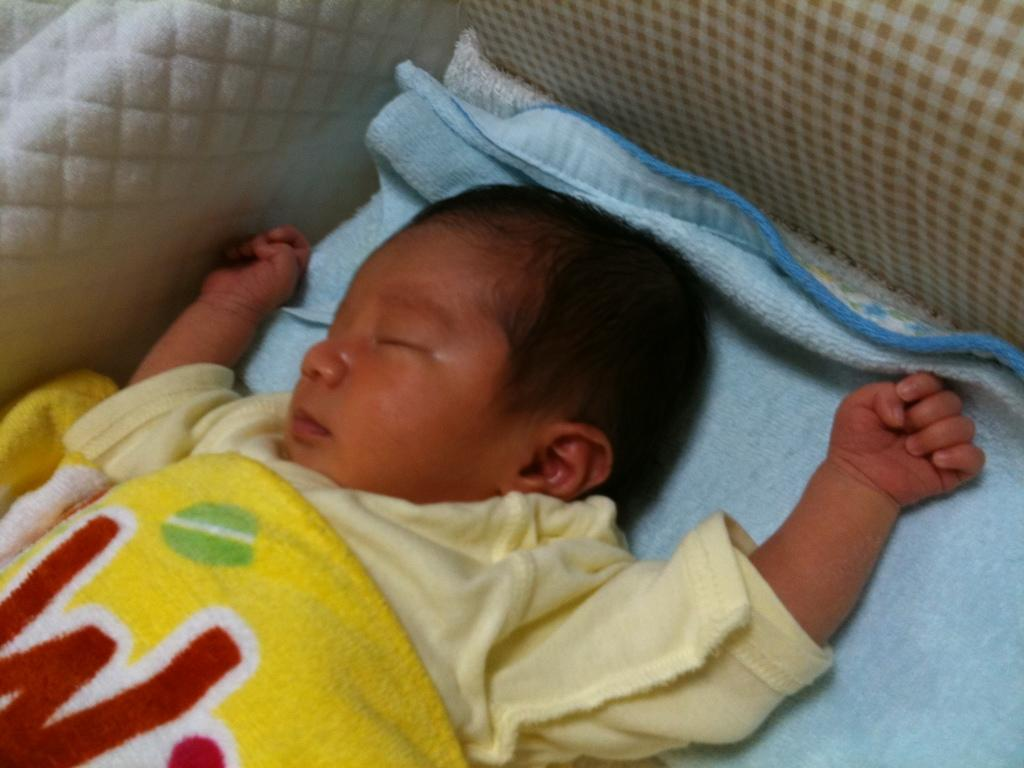What is the main subject of the image? There is a baby in the image. What is the baby doing in the image? The baby is sleeping. Where is the baby located in the image? The baby is in a cradle. How many bed sheets can be seen in the image? There are two bed sheets in the image. What type of drug is the baby taking in the image? There is no indication in the image that the baby is taking any drug. 